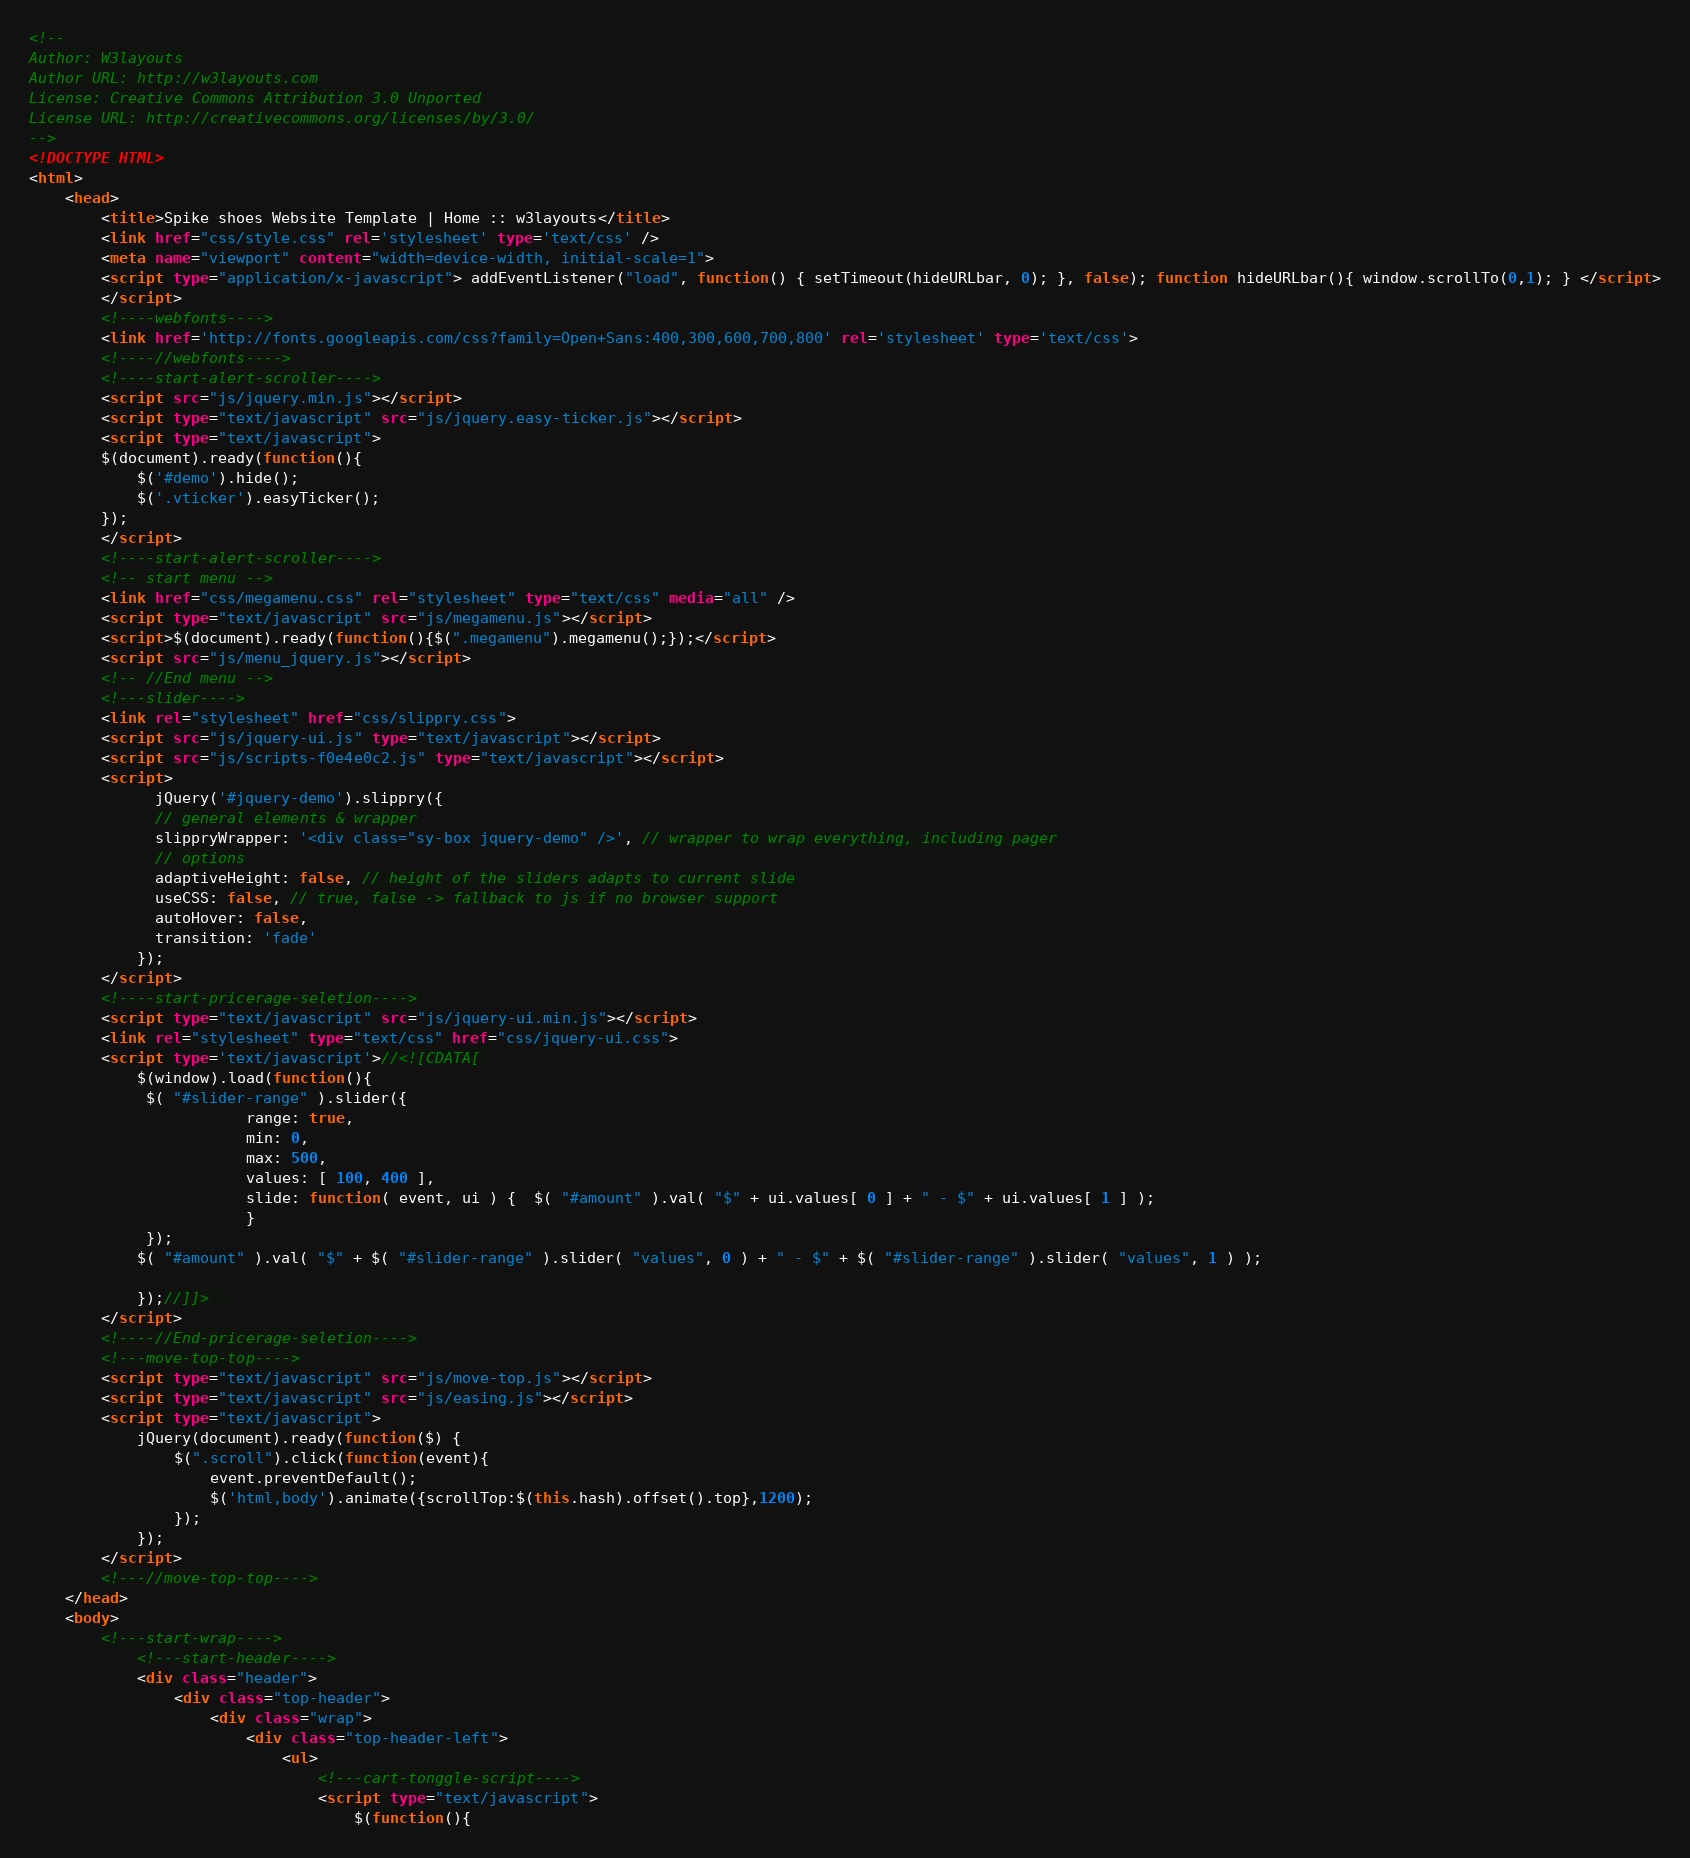<code> <loc_0><loc_0><loc_500><loc_500><_HTML_><!--
Author: W3layouts
Author URL: http://w3layouts.com
License: Creative Commons Attribution 3.0 Unported
License URL: http://creativecommons.org/licenses/by/3.0/
-->
<!DOCTYPE HTML>
<html>
	<head>
		<title>Spike shoes Website Template | Home :: w3layouts</title>
		<link href="css/style.css" rel='stylesheet' type='text/css' />
		<meta name="viewport" content="width=device-width, initial-scale=1">
		<script type="application/x-javascript"> addEventListener("load", function() { setTimeout(hideURLbar, 0); }, false); function hideURLbar(){ window.scrollTo(0,1); } </script>
		</script>
		<!----webfonts---->
		<link href='http://fonts.googleapis.com/css?family=Open+Sans:400,300,600,700,800' rel='stylesheet' type='text/css'>
		<!----//webfonts---->
		<!----start-alert-scroller---->
		<script src="js/jquery.min.js"></script>
		<script type="text/javascript" src="js/jquery.easy-ticker.js"></script>
		<script type="text/javascript">
		$(document).ready(function(){
			$('#demo').hide();
			$('.vticker').easyTicker();
		});
		</script>
		<!----start-alert-scroller---->
		<!-- start menu -->
		<link href="css/megamenu.css" rel="stylesheet" type="text/css" media="all" />
		<script type="text/javascript" src="js/megamenu.js"></script>
		<script>$(document).ready(function(){$(".megamenu").megamenu();});</script>
		<script src="js/menu_jquery.js"></script>
		<!-- //End menu -->
		<!---slider---->
		<link rel="stylesheet" href="css/slippry.css">
		<script src="js/jquery-ui.js" type="text/javascript"></script>
		<script src="js/scripts-f0e4e0c2.js" type="text/javascript"></script>
		<script>
			  jQuery('#jquery-demo').slippry({
			  // general elements & wrapper
			  slippryWrapper: '<div class="sy-box jquery-demo" />', // wrapper to wrap everything, including pager
			  // options
			  adaptiveHeight: false, // height of the sliders adapts to current slide
			  useCSS: false, // true, false -> fallback to js if no browser support
			  autoHover: false,
			  transition: 'fade'
			});
		</script>
		<!----start-pricerage-seletion---->
		<script type="text/javascript" src="js/jquery-ui.min.js"></script>
		<link rel="stylesheet" type="text/css" href="css/jquery-ui.css">
		<script type='text/javascript'>//<![CDATA[ 
			$(window).load(function(){
			 $( "#slider-range" ).slider({
			            range: true,
			            min: 0,
			            max: 500,
			            values: [ 100, 400 ],
			            slide: function( event, ui ) {  $( "#amount" ).val( "$" + ui.values[ 0 ] + " - $" + ui.values[ 1 ] );
			            }	
			 });
			$( "#amount" ).val( "$" + $( "#slider-range" ).slider( "values", 0 ) + " - $" + $( "#slider-range" ).slider( "values", 1 ) );
			
			});//]]>  
		</script>
		<!----//End-pricerage-seletion---->
		<!---move-top-top---->
		<script type="text/javascript" src="js/move-top.js"></script>
		<script type="text/javascript" src="js/easing.js"></script>
		<script type="text/javascript">
			jQuery(document).ready(function($) {
				$(".scroll").click(function(event){		
					event.preventDefault();
					$('html,body').animate({scrollTop:$(this.hash).offset().top},1200);
				});
			});
		</script>
		<!---//move-top-top---->
	</head>
	<body>
		<!---start-wrap---->
			<!---start-header---->
			<div class="header">
				<div class="top-header">
					<div class="wrap">
						<div class="top-header-left">
							<ul>
								<!---cart-tonggle-script---->
								<script type="text/javascript">
									$(function(){</code> 